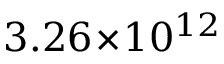<formula> <loc_0><loc_0><loc_500><loc_500>3 . 2 6 \, \times \, 1 0 ^ { 1 2 }</formula> 